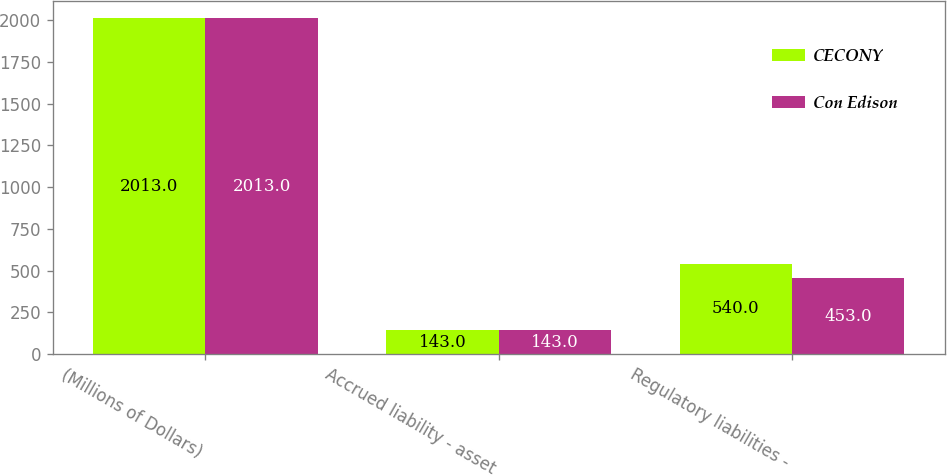<chart> <loc_0><loc_0><loc_500><loc_500><stacked_bar_chart><ecel><fcel>(Millions of Dollars)<fcel>Accrued liability - asset<fcel>Regulatory liabilities -<nl><fcel>CECONY<fcel>2013<fcel>143<fcel>540<nl><fcel>Con Edison<fcel>2013<fcel>143<fcel>453<nl></chart> 